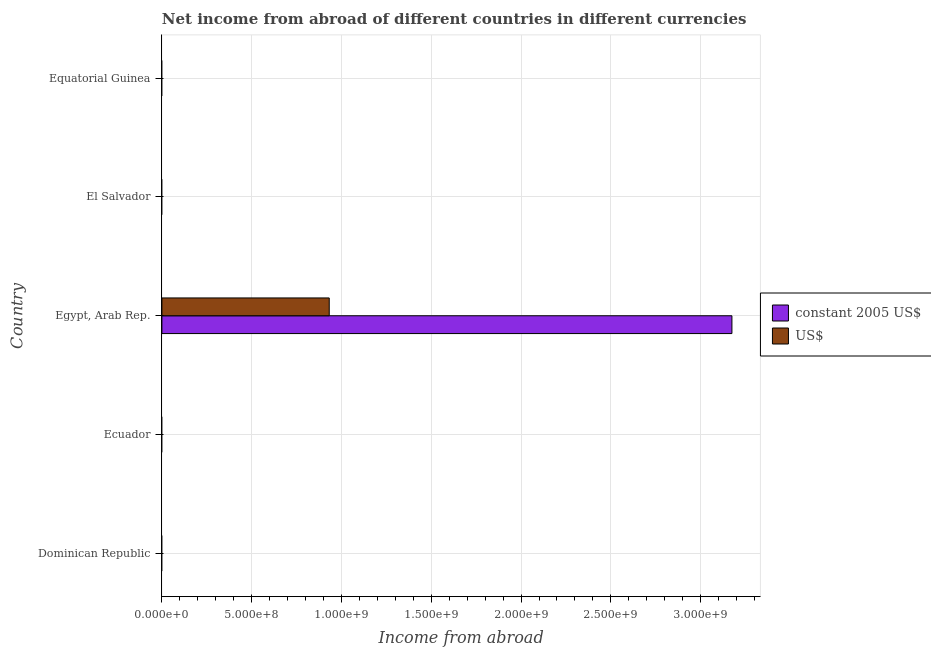Are the number of bars on each tick of the Y-axis equal?
Ensure brevity in your answer.  No. How many bars are there on the 2nd tick from the bottom?
Provide a succinct answer. 0. What is the label of the 4th group of bars from the top?
Ensure brevity in your answer.  Ecuador. In how many cases, is the number of bars for a given country not equal to the number of legend labels?
Your answer should be compact. 4. What is the income from abroad in us$ in Equatorial Guinea?
Offer a terse response. 0. Across all countries, what is the maximum income from abroad in us$?
Provide a short and direct response. 9.32e+08. In which country was the income from abroad in us$ maximum?
Give a very brief answer. Egypt, Arab Rep. What is the total income from abroad in constant 2005 us$ in the graph?
Provide a short and direct response. 3.17e+09. What is the average income from abroad in constant 2005 us$ per country?
Provide a short and direct response. 6.35e+08. What is the difference between the income from abroad in constant 2005 us$ and income from abroad in us$ in Egypt, Arab Rep.?
Your response must be concise. 2.24e+09. What is the difference between the highest and the lowest income from abroad in us$?
Your answer should be compact. 9.32e+08. In how many countries, is the income from abroad in constant 2005 us$ greater than the average income from abroad in constant 2005 us$ taken over all countries?
Ensure brevity in your answer.  1. How many bars are there?
Provide a succinct answer. 2. What is the difference between two consecutive major ticks on the X-axis?
Your answer should be very brief. 5.00e+08. Are the values on the major ticks of X-axis written in scientific E-notation?
Your answer should be very brief. Yes. Does the graph contain any zero values?
Your answer should be very brief. Yes. Where does the legend appear in the graph?
Make the answer very short. Center right. How many legend labels are there?
Your answer should be compact. 2. How are the legend labels stacked?
Provide a short and direct response. Vertical. What is the title of the graph?
Ensure brevity in your answer.  Net income from abroad of different countries in different currencies. Does "By country of origin" appear as one of the legend labels in the graph?
Offer a terse response. No. What is the label or title of the X-axis?
Give a very brief answer. Income from abroad. What is the Income from abroad of constant 2005 US$ in Egypt, Arab Rep.?
Your answer should be very brief. 3.17e+09. What is the Income from abroad of US$ in Egypt, Arab Rep.?
Keep it short and to the point. 9.32e+08. What is the Income from abroad of constant 2005 US$ in El Salvador?
Your response must be concise. 0. What is the Income from abroad of constant 2005 US$ in Equatorial Guinea?
Your answer should be very brief. 0. What is the Income from abroad in US$ in Equatorial Guinea?
Keep it short and to the point. 0. Across all countries, what is the maximum Income from abroad in constant 2005 US$?
Offer a terse response. 3.17e+09. Across all countries, what is the maximum Income from abroad in US$?
Your answer should be compact. 9.32e+08. What is the total Income from abroad in constant 2005 US$ in the graph?
Provide a short and direct response. 3.17e+09. What is the total Income from abroad of US$ in the graph?
Your answer should be compact. 9.32e+08. What is the average Income from abroad of constant 2005 US$ per country?
Offer a terse response. 6.35e+08. What is the average Income from abroad of US$ per country?
Keep it short and to the point. 1.86e+08. What is the difference between the Income from abroad in constant 2005 US$ and Income from abroad in US$ in Egypt, Arab Rep.?
Your response must be concise. 2.24e+09. What is the difference between the highest and the lowest Income from abroad of constant 2005 US$?
Ensure brevity in your answer.  3.17e+09. What is the difference between the highest and the lowest Income from abroad of US$?
Your answer should be very brief. 9.32e+08. 